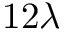Convert formula to latex. <formula><loc_0><loc_0><loc_500><loc_500>1 2 \lambda</formula> 